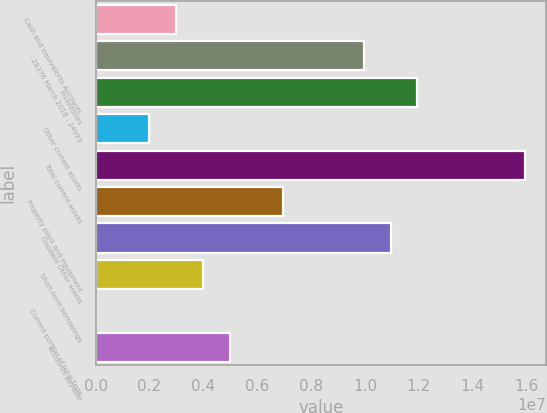Convert chart to OTSL. <chart><loc_0><loc_0><loc_500><loc_500><bar_chart><fcel>Cash and equivalents Accounts<fcel>- 28376 March 2018 - 24993<fcel>Inventories<fcel>Other current assets<fcel>Total current assets<fcel>Property plant and equipment<fcel>Goodwill Other assets<fcel>Short-term borrowings<fcel>Current portion of long-term<fcel>Accounts payable<nl><fcel>2.99187e+06<fcel>9.9585e+06<fcel>1.1949e+07<fcel>1.99663e+06<fcel>1.59299e+07<fcel>6.9728e+06<fcel>1.09537e+07<fcel>3.9871e+06<fcel>6165<fcel>4.98233e+06<nl></chart> 